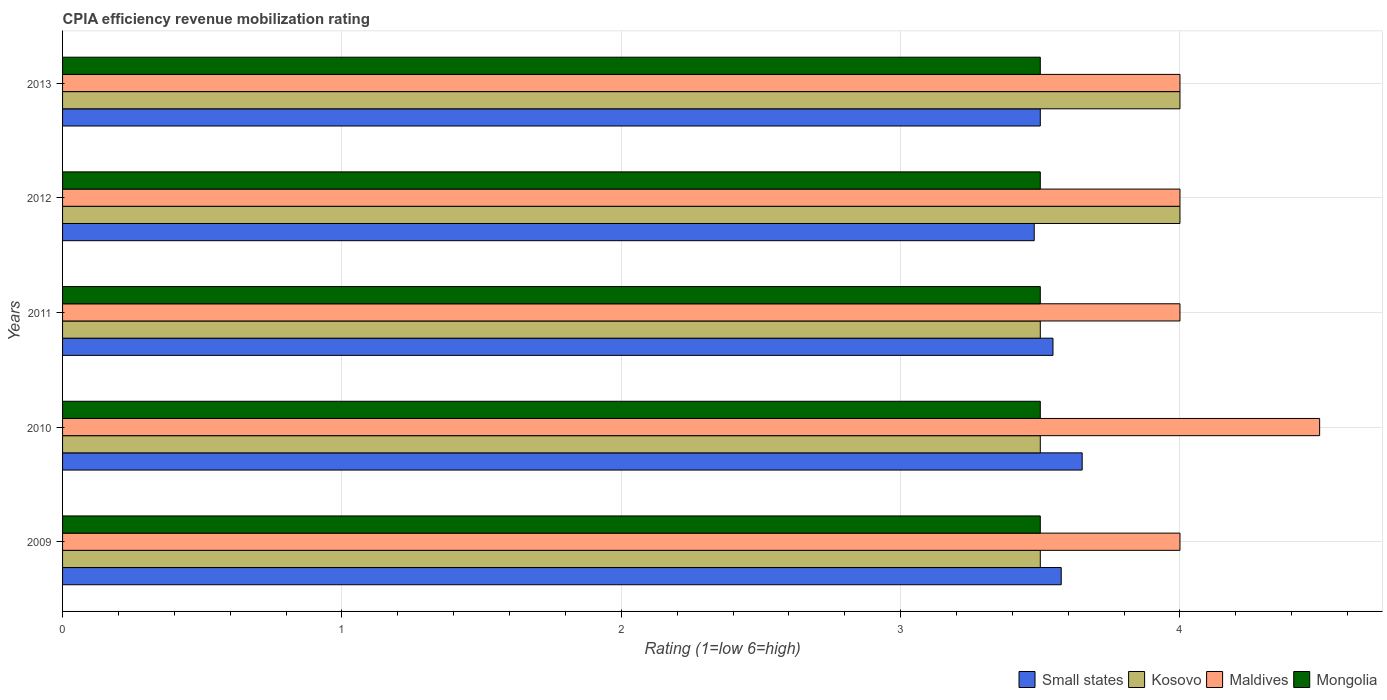Are the number of bars on each tick of the Y-axis equal?
Your answer should be very brief. Yes. What is the label of the 4th group of bars from the top?
Your answer should be compact. 2010. What is the CPIA rating in Maldives in 2013?
Your answer should be very brief. 4. Across all years, what is the maximum CPIA rating in Kosovo?
Give a very brief answer. 4. What is the difference between the CPIA rating in Small states in 2009 and the CPIA rating in Mongolia in 2012?
Your answer should be very brief. 0.08. In how many years, is the CPIA rating in Kosovo greater than 1.8 ?
Offer a terse response. 5. What is the ratio of the CPIA rating in Small states in 2009 to that in 2010?
Your answer should be compact. 0.98. Is the CPIA rating in Kosovo in 2009 less than that in 2010?
Ensure brevity in your answer.  No. What is the difference between the highest and the second highest CPIA rating in Small states?
Offer a very short reply. 0.07. What is the difference between the highest and the lowest CPIA rating in Small states?
Your answer should be very brief. 0.17. What does the 1st bar from the top in 2011 represents?
Ensure brevity in your answer.  Mongolia. What does the 3rd bar from the bottom in 2013 represents?
Provide a succinct answer. Maldives. Is it the case that in every year, the sum of the CPIA rating in Maldives and CPIA rating in Mongolia is greater than the CPIA rating in Small states?
Your answer should be very brief. Yes. How many bars are there?
Provide a succinct answer. 20. What is the difference between two consecutive major ticks on the X-axis?
Give a very brief answer. 1. Does the graph contain grids?
Offer a terse response. Yes. Where does the legend appear in the graph?
Offer a terse response. Bottom right. How many legend labels are there?
Offer a very short reply. 4. How are the legend labels stacked?
Your response must be concise. Horizontal. What is the title of the graph?
Keep it short and to the point. CPIA efficiency revenue mobilization rating. Does "Heavily indebted poor countries" appear as one of the legend labels in the graph?
Offer a very short reply. No. What is the label or title of the Y-axis?
Offer a terse response. Years. What is the Rating (1=low 6=high) of Small states in 2009?
Provide a short and direct response. 3.58. What is the Rating (1=low 6=high) of Kosovo in 2009?
Make the answer very short. 3.5. What is the Rating (1=low 6=high) of Mongolia in 2009?
Ensure brevity in your answer.  3.5. What is the Rating (1=low 6=high) in Small states in 2010?
Provide a short and direct response. 3.65. What is the Rating (1=low 6=high) of Mongolia in 2010?
Offer a terse response. 3.5. What is the Rating (1=low 6=high) in Small states in 2011?
Your answer should be compact. 3.55. What is the Rating (1=low 6=high) in Kosovo in 2011?
Offer a very short reply. 3.5. What is the Rating (1=low 6=high) in Small states in 2012?
Give a very brief answer. 3.48. What is the Rating (1=low 6=high) of Mongolia in 2012?
Your response must be concise. 3.5. What is the Rating (1=low 6=high) in Small states in 2013?
Give a very brief answer. 3.5. What is the Rating (1=low 6=high) in Kosovo in 2013?
Give a very brief answer. 4. Across all years, what is the maximum Rating (1=low 6=high) of Small states?
Provide a succinct answer. 3.65. Across all years, what is the minimum Rating (1=low 6=high) in Small states?
Keep it short and to the point. 3.48. Across all years, what is the minimum Rating (1=low 6=high) in Kosovo?
Your answer should be compact. 3.5. Across all years, what is the minimum Rating (1=low 6=high) of Maldives?
Offer a very short reply. 4. Across all years, what is the minimum Rating (1=low 6=high) of Mongolia?
Give a very brief answer. 3.5. What is the total Rating (1=low 6=high) in Small states in the graph?
Keep it short and to the point. 17.75. What is the difference between the Rating (1=low 6=high) in Small states in 2009 and that in 2010?
Make the answer very short. -0.07. What is the difference between the Rating (1=low 6=high) of Maldives in 2009 and that in 2010?
Your answer should be very brief. -0.5. What is the difference between the Rating (1=low 6=high) of Small states in 2009 and that in 2011?
Make the answer very short. 0.03. What is the difference between the Rating (1=low 6=high) in Kosovo in 2009 and that in 2011?
Give a very brief answer. 0. What is the difference between the Rating (1=low 6=high) of Maldives in 2009 and that in 2011?
Make the answer very short. 0. What is the difference between the Rating (1=low 6=high) in Mongolia in 2009 and that in 2011?
Provide a short and direct response. 0. What is the difference between the Rating (1=low 6=high) of Small states in 2009 and that in 2012?
Offer a terse response. 0.1. What is the difference between the Rating (1=low 6=high) in Maldives in 2009 and that in 2012?
Offer a very short reply. 0. What is the difference between the Rating (1=low 6=high) of Mongolia in 2009 and that in 2012?
Offer a very short reply. 0. What is the difference between the Rating (1=low 6=high) of Small states in 2009 and that in 2013?
Your answer should be very brief. 0.07. What is the difference between the Rating (1=low 6=high) in Small states in 2010 and that in 2011?
Offer a very short reply. 0.1. What is the difference between the Rating (1=low 6=high) of Kosovo in 2010 and that in 2011?
Ensure brevity in your answer.  0. What is the difference between the Rating (1=low 6=high) in Small states in 2010 and that in 2012?
Offer a terse response. 0.17. What is the difference between the Rating (1=low 6=high) of Maldives in 2010 and that in 2012?
Ensure brevity in your answer.  0.5. What is the difference between the Rating (1=low 6=high) in Small states in 2010 and that in 2013?
Your answer should be compact. 0.15. What is the difference between the Rating (1=low 6=high) in Kosovo in 2010 and that in 2013?
Provide a succinct answer. -0.5. What is the difference between the Rating (1=low 6=high) of Maldives in 2010 and that in 2013?
Your answer should be very brief. 0.5. What is the difference between the Rating (1=low 6=high) of Small states in 2011 and that in 2012?
Ensure brevity in your answer.  0.07. What is the difference between the Rating (1=low 6=high) of Maldives in 2011 and that in 2012?
Your answer should be very brief. 0. What is the difference between the Rating (1=low 6=high) in Small states in 2011 and that in 2013?
Keep it short and to the point. 0.05. What is the difference between the Rating (1=low 6=high) of Kosovo in 2011 and that in 2013?
Provide a succinct answer. -0.5. What is the difference between the Rating (1=low 6=high) in Maldives in 2011 and that in 2013?
Give a very brief answer. 0. What is the difference between the Rating (1=low 6=high) in Small states in 2012 and that in 2013?
Provide a succinct answer. -0.02. What is the difference between the Rating (1=low 6=high) in Kosovo in 2012 and that in 2013?
Offer a terse response. 0. What is the difference between the Rating (1=low 6=high) of Small states in 2009 and the Rating (1=low 6=high) of Kosovo in 2010?
Provide a succinct answer. 0.07. What is the difference between the Rating (1=low 6=high) of Small states in 2009 and the Rating (1=low 6=high) of Maldives in 2010?
Ensure brevity in your answer.  -0.93. What is the difference between the Rating (1=low 6=high) in Small states in 2009 and the Rating (1=low 6=high) in Mongolia in 2010?
Your answer should be compact. 0.07. What is the difference between the Rating (1=low 6=high) in Kosovo in 2009 and the Rating (1=low 6=high) in Mongolia in 2010?
Offer a very short reply. 0. What is the difference between the Rating (1=low 6=high) of Maldives in 2009 and the Rating (1=low 6=high) of Mongolia in 2010?
Offer a very short reply. 0.5. What is the difference between the Rating (1=low 6=high) in Small states in 2009 and the Rating (1=low 6=high) in Kosovo in 2011?
Ensure brevity in your answer.  0.07. What is the difference between the Rating (1=low 6=high) in Small states in 2009 and the Rating (1=low 6=high) in Maldives in 2011?
Provide a short and direct response. -0.42. What is the difference between the Rating (1=low 6=high) in Small states in 2009 and the Rating (1=low 6=high) in Mongolia in 2011?
Provide a short and direct response. 0.07. What is the difference between the Rating (1=low 6=high) in Kosovo in 2009 and the Rating (1=low 6=high) in Maldives in 2011?
Make the answer very short. -0.5. What is the difference between the Rating (1=low 6=high) in Small states in 2009 and the Rating (1=low 6=high) in Kosovo in 2012?
Your answer should be very brief. -0.42. What is the difference between the Rating (1=low 6=high) of Small states in 2009 and the Rating (1=low 6=high) of Maldives in 2012?
Offer a terse response. -0.42. What is the difference between the Rating (1=low 6=high) of Small states in 2009 and the Rating (1=low 6=high) of Mongolia in 2012?
Offer a terse response. 0.07. What is the difference between the Rating (1=low 6=high) in Kosovo in 2009 and the Rating (1=low 6=high) in Maldives in 2012?
Ensure brevity in your answer.  -0.5. What is the difference between the Rating (1=low 6=high) in Maldives in 2009 and the Rating (1=low 6=high) in Mongolia in 2012?
Your answer should be very brief. 0.5. What is the difference between the Rating (1=low 6=high) of Small states in 2009 and the Rating (1=low 6=high) of Kosovo in 2013?
Make the answer very short. -0.42. What is the difference between the Rating (1=low 6=high) in Small states in 2009 and the Rating (1=low 6=high) in Maldives in 2013?
Your answer should be compact. -0.42. What is the difference between the Rating (1=low 6=high) in Small states in 2009 and the Rating (1=low 6=high) in Mongolia in 2013?
Offer a terse response. 0.07. What is the difference between the Rating (1=low 6=high) in Kosovo in 2009 and the Rating (1=low 6=high) in Maldives in 2013?
Provide a short and direct response. -0.5. What is the difference between the Rating (1=low 6=high) in Kosovo in 2009 and the Rating (1=low 6=high) in Mongolia in 2013?
Offer a very short reply. 0. What is the difference between the Rating (1=low 6=high) of Small states in 2010 and the Rating (1=low 6=high) of Maldives in 2011?
Offer a very short reply. -0.35. What is the difference between the Rating (1=low 6=high) in Kosovo in 2010 and the Rating (1=low 6=high) in Mongolia in 2011?
Ensure brevity in your answer.  0. What is the difference between the Rating (1=low 6=high) in Small states in 2010 and the Rating (1=low 6=high) in Kosovo in 2012?
Your answer should be very brief. -0.35. What is the difference between the Rating (1=low 6=high) in Small states in 2010 and the Rating (1=low 6=high) in Maldives in 2012?
Keep it short and to the point. -0.35. What is the difference between the Rating (1=low 6=high) in Small states in 2010 and the Rating (1=low 6=high) in Mongolia in 2012?
Your response must be concise. 0.15. What is the difference between the Rating (1=low 6=high) of Kosovo in 2010 and the Rating (1=low 6=high) of Maldives in 2012?
Give a very brief answer. -0.5. What is the difference between the Rating (1=low 6=high) in Small states in 2010 and the Rating (1=low 6=high) in Kosovo in 2013?
Your answer should be very brief. -0.35. What is the difference between the Rating (1=low 6=high) in Small states in 2010 and the Rating (1=low 6=high) in Maldives in 2013?
Provide a short and direct response. -0.35. What is the difference between the Rating (1=low 6=high) in Small states in 2011 and the Rating (1=low 6=high) in Kosovo in 2012?
Your answer should be very brief. -0.45. What is the difference between the Rating (1=low 6=high) in Small states in 2011 and the Rating (1=low 6=high) in Maldives in 2012?
Ensure brevity in your answer.  -0.45. What is the difference between the Rating (1=low 6=high) of Small states in 2011 and the Rating (1=low 6=high) of Mongolia in 2012?
Offer a terse response. 0.05. What is the difference between the Rating (1=low 6=high) of Small states in 2011 and the Rating (1=low 6=high) of Kosovo in 2013?
Your answer should be compact. -0.45. What is the difference between the Rating (1=low 6=high) in Small states in 2011 and the Rating (1=low 6=high) in Maldives in 2013?
Your answer should be compact. -0.45. What is the difference between the Rating (1=low 6=high) of Small states in 2011 and the Rating (1=low 6=high) of Mongolia in 2013?
Your answer should be compact. 0.05. What is the difference between the Rating (1=low 6=high) in Kosovo in 2011 and the Rating (1=low 6=high) in Mongolia in 2013?
Make the answer very short. 0. What is the difference between the Rating (1=low 6=high) of Small states in 2012 and the Rating (1=low 6=high) of Kosovo in 2013?
Your answer should be compact. -0.52. What is the difference between the Rating (1=low 6=high) of Small states in 2012 and the Rating (1=low 6=high) of Maldives in 2013?
Make the answer very short. -0.52. What is the difference between the Rating (1=low 6=high) of Small states in 2012 and the Rating (1=low 6=high) of Mongolia in 2013?
Provide a short and direct response. -0.02. What is the average Rating (1=low 6=high) of Small states per year?
Your answer should be compact. 3.55. What is the average Rating (1=low 6=high) of Maldives per year?
Provide a short and direct response. 4.1. In the year 2009, what is the difference between the Rating (1=low 6=high) in Small states and Rating (1=low 6=high) in Kosovo?
Give a very brief answer. 0.07. In the year 2009, what is the difference between the Rating (1=low 6=high) in Small states and Rating (1=low 6=high) in Maldives?
Your answer should be compact. -0.42. In the year 2009, what is the difference between the Rating (1=low 6=high) in Small states and Rating (1=low 6=high) in Mongolia?
Your answer should be very brief. 0.07. In the year 2010, what is the difference between the Rating (1=low 6=high) of Small states and Rating (1=low 6=high) of Kosovo?
Your answer should be very brief. 0.15. In the year 2010, what is the difference between the Rating (1=low 6=high) in Small states and Rating (1=low 6=high) in Maldives?
Your response must be concise. -0.85. In the year 2010, what is the difference between the Rating (1=low 6=high) in Small states and Rating (1=low 6=high) in Mongolia?
Your answer should be compact. 0.15. In the year 2010, what is the difference between the Rating (1=low 6=high) in Kosovo and Rating (1=low 6=high) in Maldives?
Your answer should be compact. -1. In the year 2010, what is the difference between the Rating (1=low 6=high) in Kosovo and Rating (1=low 6=high) in Mongolia?
Your answer should be very brief. 0. In the year 2010, what is the difference between the Rating (1=low 6=high) of Maldives and Rating (1=low 6=high) of Mongolia?
Offer a very short reply. 1. In the year 2011, what is the difference between the Rating (1=low 6=high) in Small states and Rating (1=low 6=high) in Kosovo?
Provide a succinct answer. 0.05. In the year 2011, what is the difference between the Rating (1=low 6=high) of Small states and Rating (1=low 6=high) of Maldives?
Ensure brevity in your answer.  -0.45. In the year 2011, what is the difference between the Rating (1=low 6=high) in Small states and Rating (1=low 6=high) in Mongolia?
Make the answer very short. 0.05. In the year 2012, what is the difference between the Rating (1=low 6=high) in Small states and Rating (1=low 6=high) in Kosovo?
Ensure brevity in your answer.  -0.52. In the year 2012, what is the difference between the Rating (1=low 6=high) of Small states and Rating (1=low 6=high) of Maldives?
Make the answer very short. -0.52. In the year 2012, what is the difference between the Rating (1=low 6=high) in Small states and Rating (1=low 6=high) in Mongolia?
Your answer should be compact. -0.02. In the year 2012, what is the difference between the Rating (1=low 6=high) of Kosovo and Rating (1=low 6=high) of Maldives?
Your response must be concise. 0. In the year 2012, what is the difference between the Rating (1=low 6=high) in Maldives and Rating (1=low 6=high) in Mongolia?
Ensure brevity in your answer.  0.5. In the year 2013, what is the difference between the Rating (1=low 6=high) in Small states and Rating (1=low 6=high) in Kosovo?
Provide a succinct answer. -0.5. In the year 2013, what is the difference between the Rating (1=low 6=high) of Kosovo and Rating (1=low 6=high) of Mongolia?
Offer a very short reply. 0.5. In the year 2013, what is the difference between the Rating (1=low 6=high) of Maldives and Rating (1=low 6=high) of Mongolia?
Make the answer very short. 0.5. What is the ratio of the Rating (1=low 6=high) in Small states in 2009 to that in 2010?
Make the answer very short. 0.98. What is the ratio of the Rating (1=low 6=high) of Maldives in 2009 to that in 2010?
Ensure brevity in your answer.  0.89. What is the ratio of the Rating (1=low 6=high) of Mongolia in 2009 to that in 2010?
Offer a very short reply. 1. What is the ratio of the Rating (1=low 6=high) of Small states in 2009 to that in 2011?
Ensure brevity in your answer.  1.01. What is the ratio of the Rating (1=low 6=high) in Mongolia in 2009 to that in 2011?
Keep it short and to the point. 1. What is the ratio of the Rating (1=low 6=high) in Small states in 2009 to that in 2012?
Provide a succinct answer. 1.03. What is the ratio of the Rating (1=low 6=high) of Kosovo in 2009 to that in 2012?
Your answer should be very brief. 0.88. What is the ratio of the Rating (1=low 6=high) in Maldives in 2009 to that in 2012?
Your answer should be compact. 1. What is the ratio of the Rating (1=low 6=high) of Mongolia in 2009 to that in 2012?
Offer a very short reply. 1. What is the ratio of the Rating (1=low 6=high) of Small states in 2009 to that in 2013?
Provide a succinct answer. 1.02. What is the ratio of the Rating (1=low 6=high) of Small states in 2010 to that in 2011?
Your answer should be very brief. 1.03. What is the ratio of the Rating (1=low 6=high) in Small states in 2010 to that in 2012?
Your response must be concise. 1.05. What is the ratio of the Rating (1=low 6=high) in Kosovo in 2010 to that in 2012?
Provide a succinct answer. 0.88. What is the ratio of the Rating (1=low 6=high) in Maldives in 2010 to that in 2012?
Give a very brief answer. 1.12. What is the ratio of the Rating (1=low 6=high) of Mongolia in 2010 to that in 2012?
Provide a short and direct response. 1. What is the ratio of the Rating (1=low 6=high) of Small states in 2010 to that in 2013?
Keep it short and to the point. 1.04. What is the ratio of the Rating (1=low 6=high) in Kosovo in 2010 to that in 2013?
Your response must be concise. 0.88. What is the ratio of the Rating (1=low 6=high) of Mongolia in 2010 to that in 2013?
Your answer should be very brief. 1. What is the ratio of the Rating (1=low 6=high) of Small states in 2011 to that in 2012?
Your answer should be compact. 1.02. What is the ratio of the Rating (1=low 6=high) in Maldives in 2011 to that in 2012?
Your answer should be compact. 1. What is the ratio of the Rating (1=low 6=high) of Mongolia in 2011 to that in 2012?
Your answer should be compact. 1. What is the ratio of the Rating (1=low 6=high) in Small states in 2011 to that in 2013?
Offer a terse response. 1.01. What is the ratio of the Rating (1=low 6=high) in Mongolia in 2011 to that in 2013?
Offer a terse response. 1. What is the ratio of the Rating (1=low 6=high) of Small states in 2012 to that in 2013?
Give a very brief answer. 0.99. What is the ratio of the Rating (1=low 6=high) of Kosovo in 2012 to that in 2013?
Offer a terse response. 1. What is the ratio of the Rating (1=low 6=high) of Maldives in 2012 to that in 2013?
Keep it short and to the point. 1. What is the difference between the highest and the second highest Rating (1=low 6=high) of Small states?
Provide a succinct answer. 0.07. What is the difference between the highest and the second highest Rating (1=low 6=high) in Kosovo?
Provide a succinct answer. 0. What is the difference between the highest and the lowest Rating (1=low 6=high) of Small states?
Your response must be concise. 0.17. What is the difference between the highest and the lowest Rating (1=low 6=high) in Kosovo?
Make the answer very short. 0.5. What is the difference between the highest and the lowest Rating (1=low 6=high) of Maldives?
Provide a succinct answer. 0.5. 